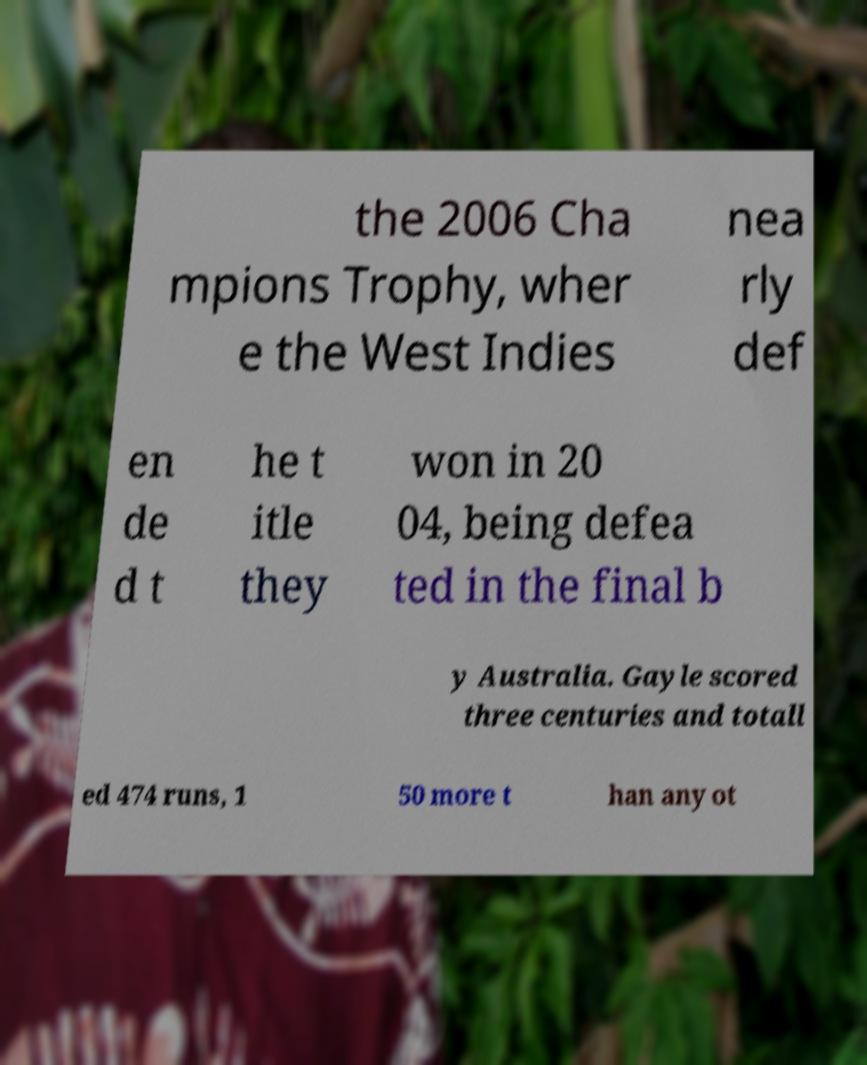What messages or text are displayed in this image? I need them in a readable, typed format. the 2006 Cha mpions Trophy, wher e the West Indies nea rly def en de d t he t itle they won in 20 04, being defea ted in the final b y Australia. Gayle scored three centuries and totall ed 474 runs, 1 50 more t han any ot 